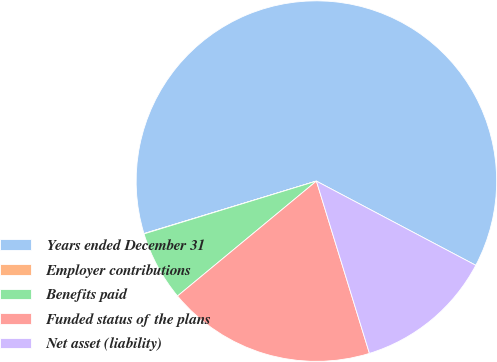Convert chart to OTSL. <chart><loc_0><loc_0><loc_500><loc_500><pie_chart><fcel>Years ended December 31<fcel>Employer contributions<fcel>Benefits paid<fcel>Funded status of the plans<fcel>Net asset (liability)<nl><fcel>62.43%<fcel>0.03%<fcel>6.27%<fcel>18.75%<fcel>12.51%<nl></chart> 